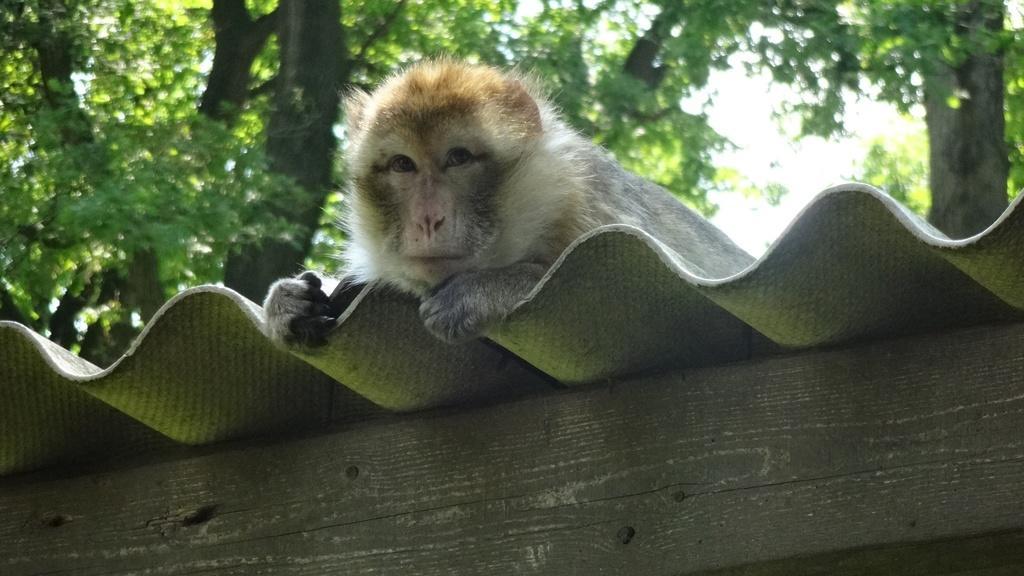How would you summarize this image in a sentence or two? In this image we can see a monkey on the asbestos sheet. At the bottom there is a wooden block. In the background there are trees and sky. 